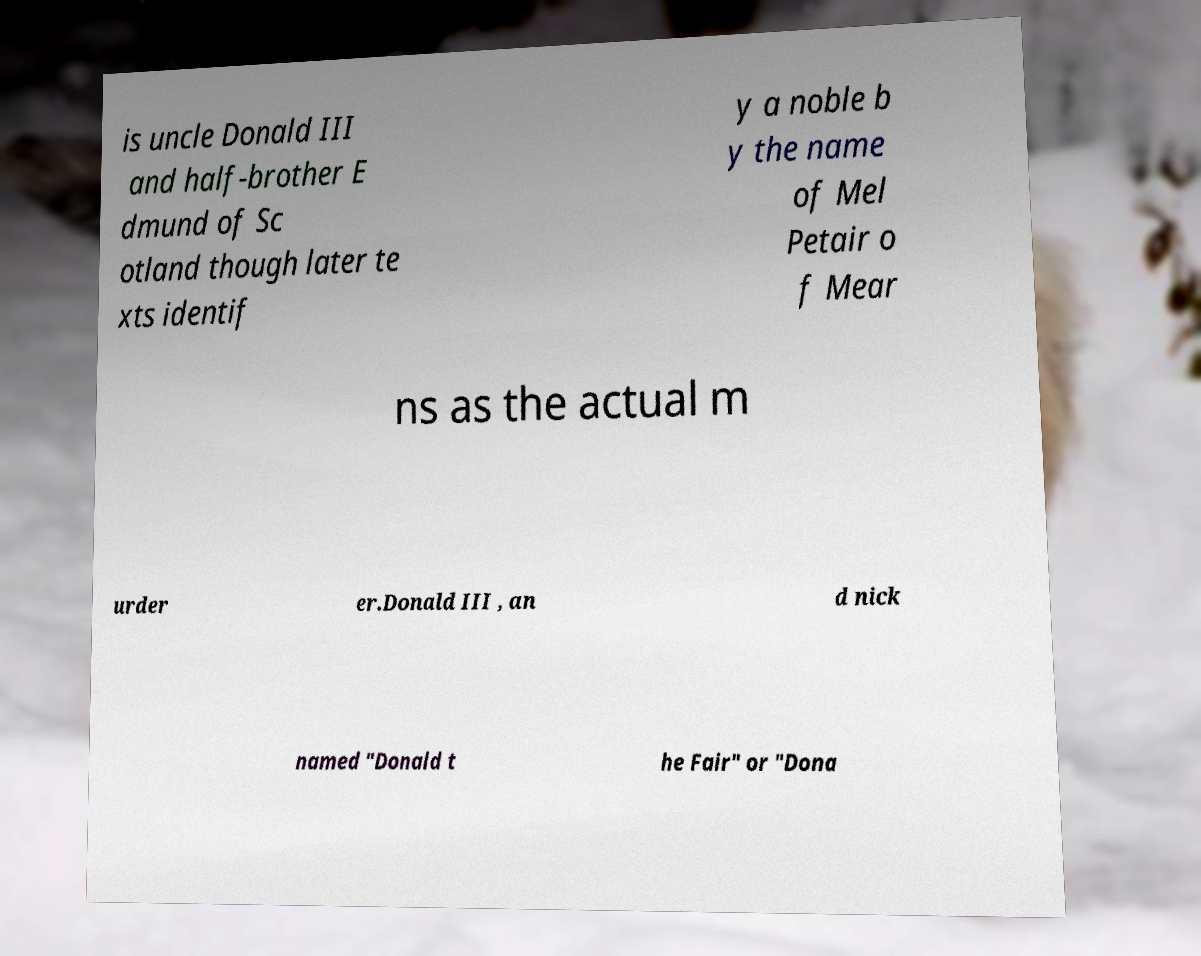What messages or text are displayed in this image? I need them in a readable, typed format. is uncle Donald III and half-brother E dmund of Sc otland though later te xts identif y a noble b y the name of Mel Petair o f Mear ns as the actual m urder er.Donald III , an d nick named "Donald t he Fair" or "Dona 